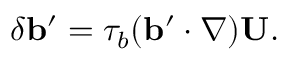<formula> <loc_0><loc_0><loc_500><loc_500>\delta { b } ^ { \prime } = \tau _ { b } ( { b } ^ { \prime } \cdot \nabla ) { U } .</formula> 